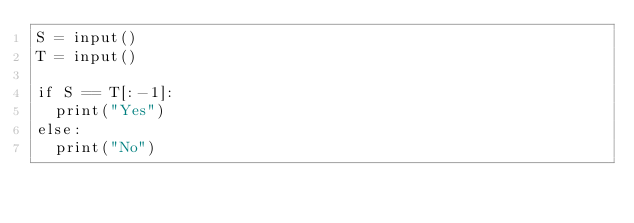<code> <loc_0><loc_0><loc_500><loc_500><_Python_>S = input()
T = input()

if S == T[:-1]:
  print("Yes")
else:
  print("No")
</code> 